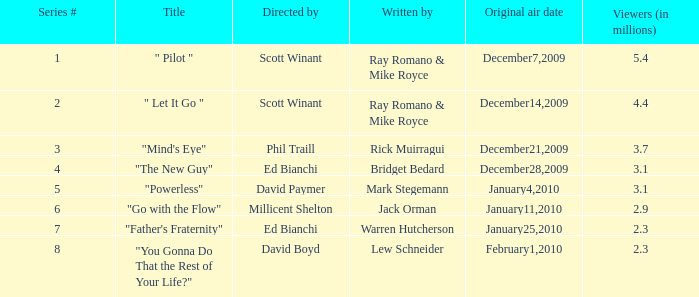How many episodes are authored by lew schneider? 1.0. 